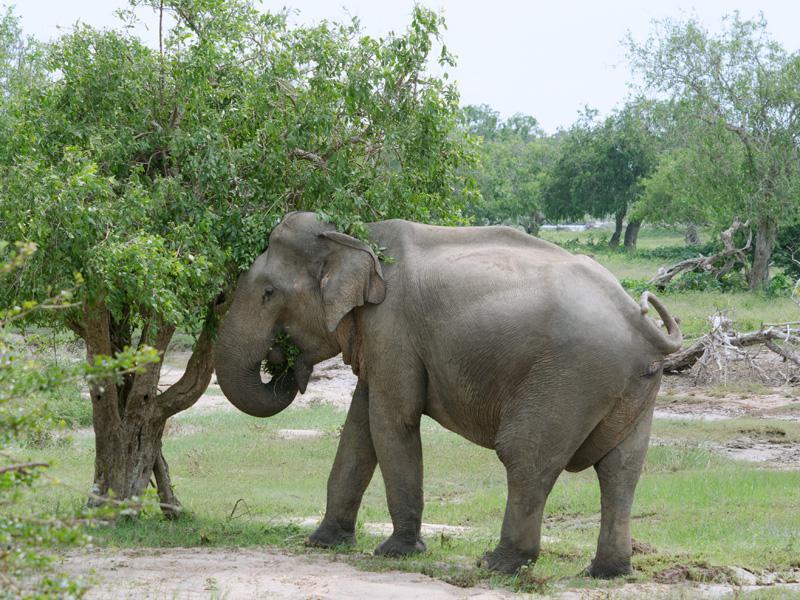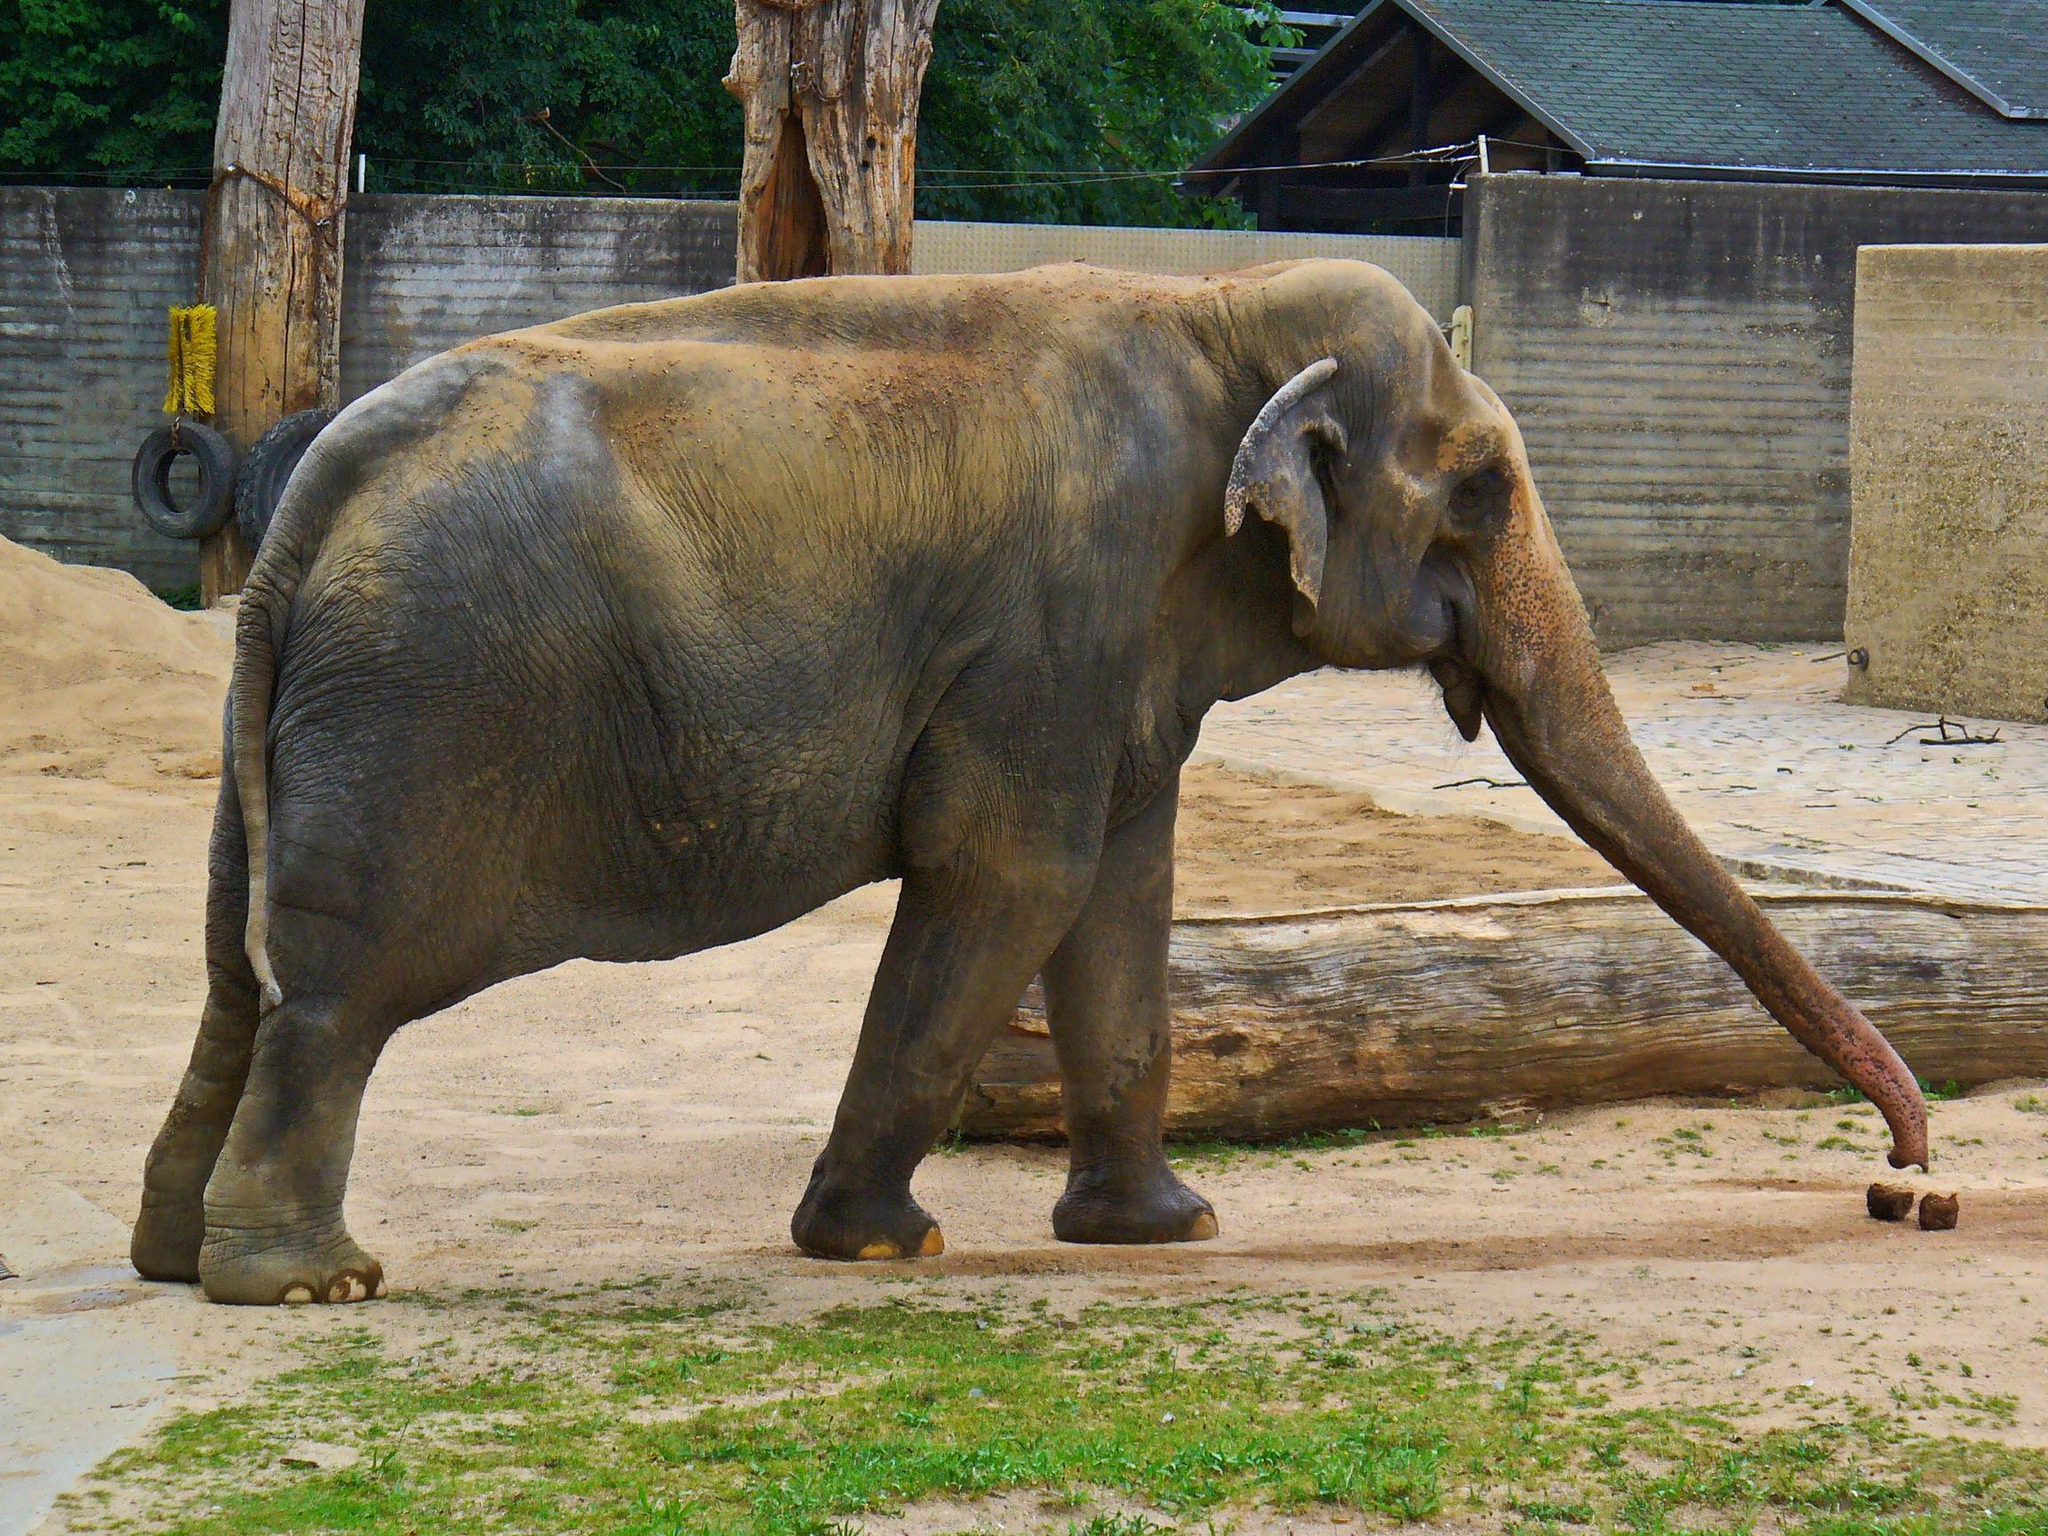The first image is the image on the left, the second image is the image on the right. Evaluate the accuracy of this statement regarding the images: "There are no baby elephants in the images.". Is it true? Answer yes or no. Yes. The first image is the image on the left, the second image is the image on the right. Given the left and right images, does the statement "Each image contains multiple elephants, and the right image includes a baby elephant." hold true? Answer yes or no. No. 